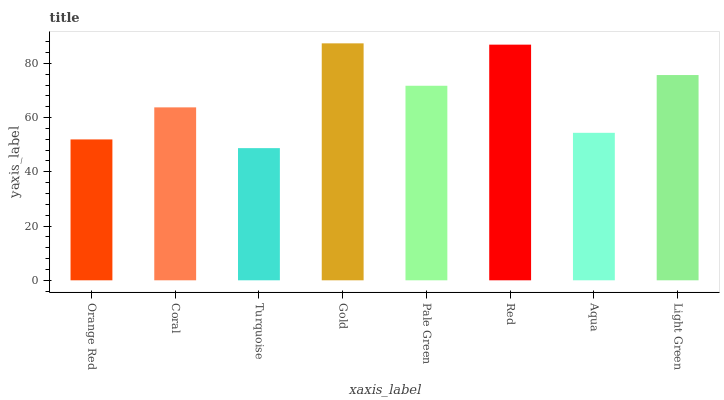Is Turquoise the minimum?
Answer yes or no. Yes. Is Gold the maximum?
Answer yes or no. Yes. Is Coral the minimum?
Answer yes or no. No. Is Coral the maximum?
Answer yes or no. No. Is Coral greater than Orange Red?
Answer yes or no. Yes. Is Orange Red less than Coral?
Answer yes or no. Yes. Is Orange Red greater than Coral?
Answer yes or no. No. Is Coral less than Orange Red?
Answer yes or no. No. Is Pale Green the high median?
Answer yes or no. Yes. Is Coral the low median?
Answer yes or no. Yes. Is Coral the high median?
Answer yes or no. No. Is Gold the low median?
Answer yes or no. No. 